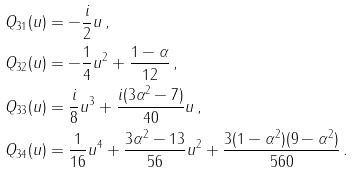<formula> <loc_0><loc_0><loc_500><loc_500>Q _ { 3 1 } ( u ) & = - \frac { i } { 2 } u \, , \\ Q _ { 3 2 } ( u ) & = - \frac { 1 } { 4 } u ^ { 2 } + \frac { 1 - \alpha } { 1 2 } \, , \\ Q _ { 3 3 } ( u ) & = \frac { i } { 8 } u ^ { 3 } + \frac { i ( 3 \alpha ^ { 2 } - 7 ) } { 4 0 } u \, , \\ Q _ { 3 4 } ( u ) & = \frac { 1 } { 1 6 } u ^ { 4 } + \frac { 3 \alpha ^ { 2 } - 1 3 } { 5 6 } u ^ { 2 } + \frac { 3 ( 1 - \alpha ^ { 2 } ) ( 9 - \alpha ^ { 2 } ) } { 5 6 0 } \, .</formula> 